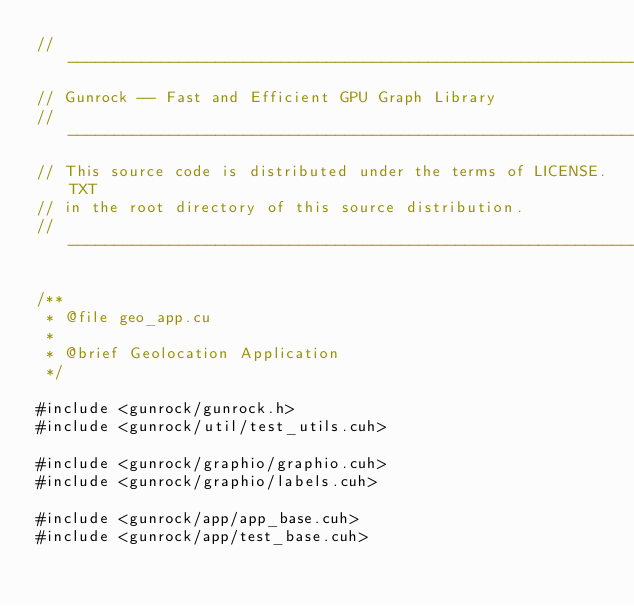<code> <loc_0><loc_0><loc_500><loc_500><_Cuda_>// ----------------------------------------------------------------------------
// Gunrock -- Fast and Efficient GPU Graph Library
// ----------------------------------------------------------------------------
// This source code is distributed under the terms of LICENSE.TXT
// in the root directory of this source distribution.
// ----------------------------------------------------------------------------

/**
 * @file geo_app.cu
 *
 * @brief Geolocation Application
 */

#include <gunrock/gunrock.h>
#include <gunrock/util/test_utils.cuh>

#include <gunrock/graphio/graphio.cuh>
#include <gunrock/graphio/labels.cuh>

#include <gunrock/app/app_base.cuh>
#include <gunrock/app/test_base.cuh>
</code> 